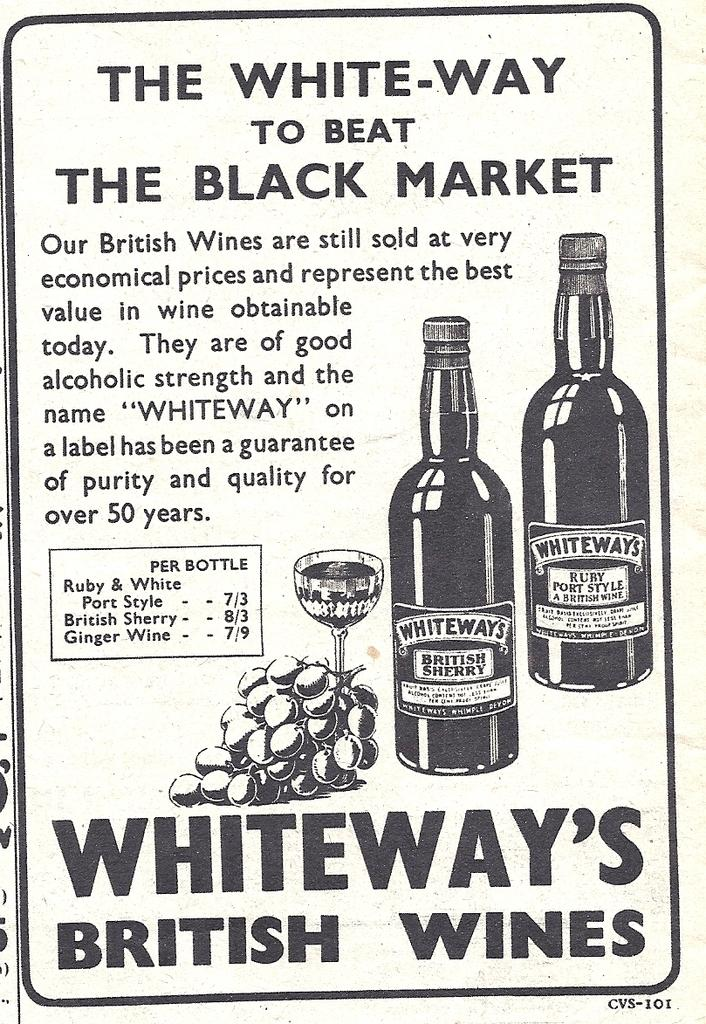What is the main subject of the poster in the image? The poster contains notes, a sketch of grapes, a sketch of a glass, and a sketch of bottles. What type of drawing is included on the poster? The poster includes a sketch of grapes, a glass, and bottles. What is the purpose of the notes on the poster? The purpose of the notes on the poster is not specified in the facts provided. What type of alarm can be heard going off in the image? There is no alarm present in the image; it only contains a poster with notes and sketches. How does the fog affect the visibility of the poster in the image? There is no fog present in the image; it is a clear image of the poster. 